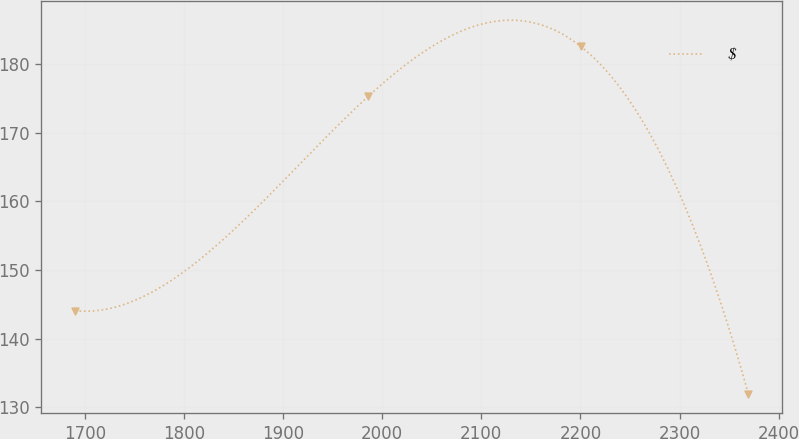Convert chart. <chart><loc_0><loc_0><loc_500><loc_500><line_chart><ecel><fcel>$<nl><fcel>1690.27<fcel>144.07<nl><fcel>1986<fcel>175.34<nl><fcel>2200.46<fcel>182.61<nl><fcel>2369.48<fcel>131.86<nl></chart> 